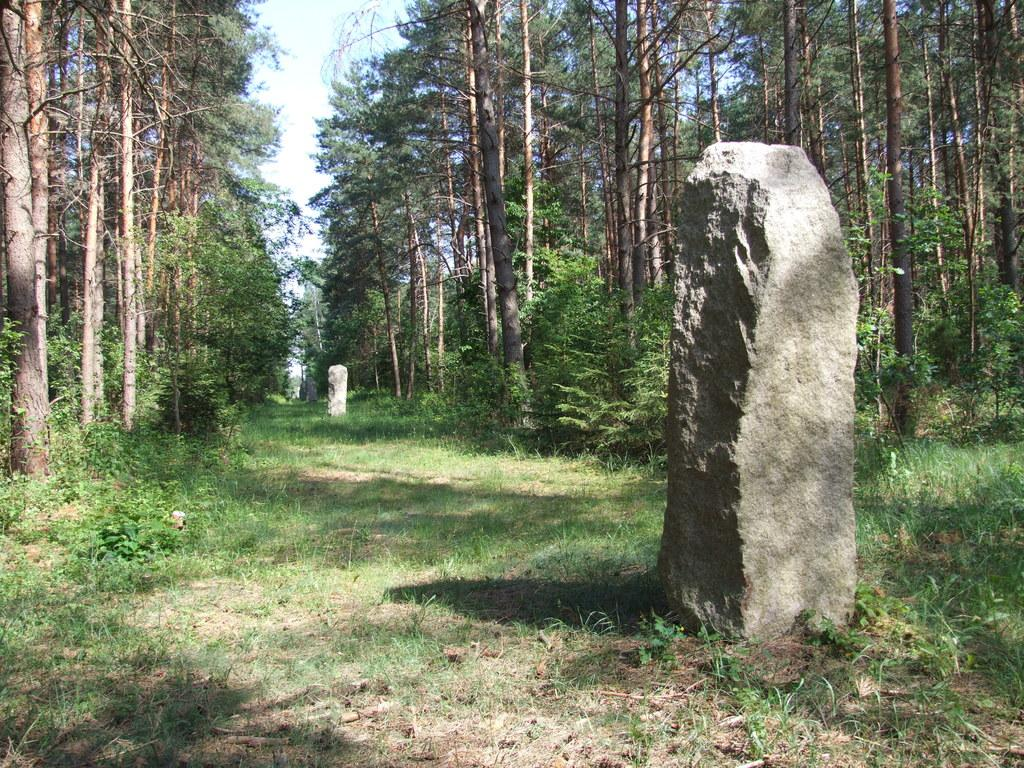What type of vegetation can be seen in the image? There are trees and plants in the image. What is on the ground in the image? There is grass on the ground in the image. What are the two stones in the image used for? The purpose of the two stones in the image is not specified. What is visible at the top of the image? The sky is visible at the top of the image. How many eyes can be seen on the beggar in the image? There is no beggar present in the image, so there are no eyes to count. What is the hope for the future of the plants in the image? The image does not provide any information about the future of the plants, so it is impossible to determine their hope for the future. 